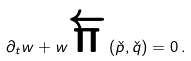Convert formula to latex. <formula><loc_0><loc_0><loc_500><loc_500>\partial _ { t } w + w { \overleftarrow { \Pi } } \left ( { \check { p } } , { \check { q } } \right ) = 0 \, .</formula> 